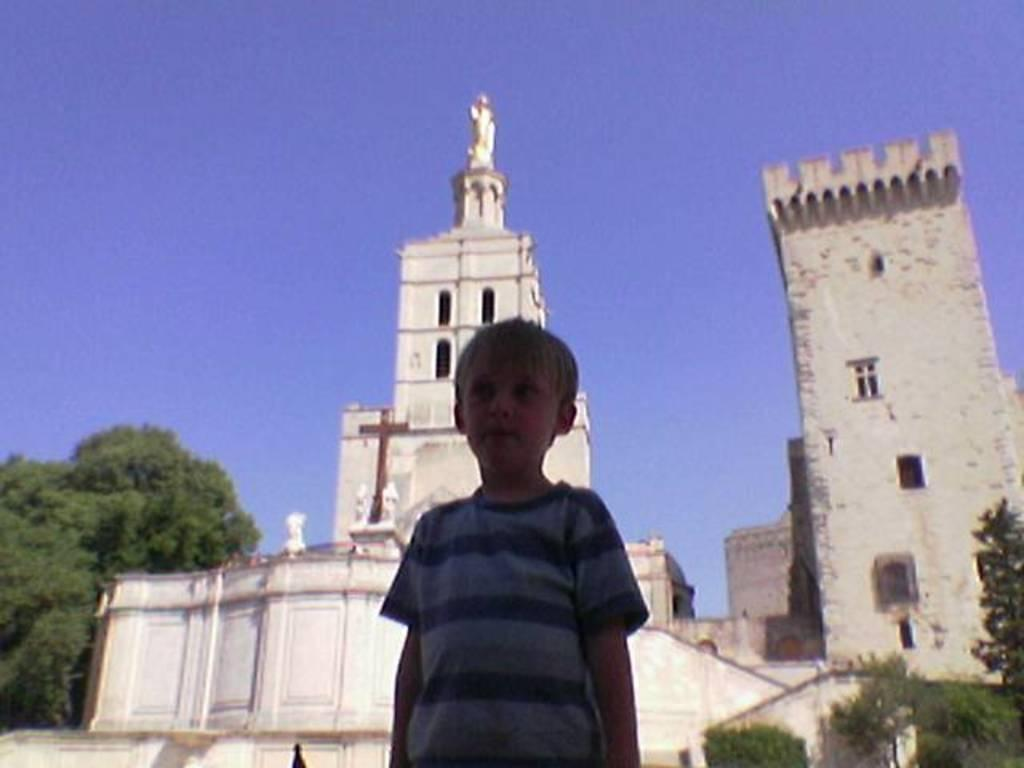What is the person in the image wearing? The person in the image is wearing a blue dress. What can be seen in the background of the image? There are trees and buildings in the background of the image. What color are the buildings in the background? The buildings in the background are white. What is the color of the sky in the background of the image? The sky is blue in the background of the image. What is the person's opinion about the plough in the image? There is no plough present in the image, so it is not possible to determine the person's opinion about it. 